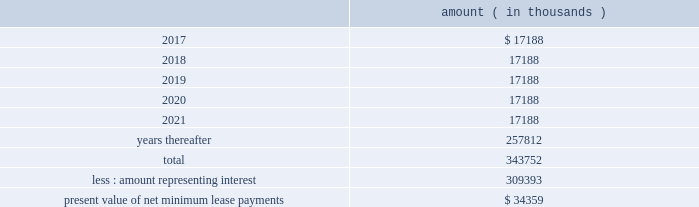Entergy corporation and subsidiaries notes to financial statements liability to $ 60 million , and recorded the $ 2.7 million difference as a credit to interest expense .
The $ 60 million remaining liability was eliminated upon payment of the cash portion of the purchase price .
As of december 31 , 2016 , entergy louisiana , in connection with the waterford 3 lease obligation , had a future minimum lease payment ( reflecting an interest rate of 8.09% ( 8.09 % ) ) of $ 57.5 million , including $ 2.3 million in interest , due january 2017 that is recorded as long-term debt .
In february 2017 the leases were terminated and the leased assets were conveyed to entergy louisiana .
Grand gulf lease obligations in 1988 , in two separate but substantially identical transactions , system energy sold and leased back undivided ownership interests in grand gulf for the aggregate sum of $ 500 million .
The initial term of the leases expired in july 2015 .
System energy renewed the leases for fair market value with renewal terms expiring in july 2036 .
At the end of the new lease renewal terms , system energy has the option to repurchase the leased interests in grand gulf or renew the leases at fair market value .
In the event that system energy does not renew or purchase the interests , system energy would surrender such interests and their associated entitlement of grand gulf 2019s capacity and energy .
System energy is required to report the sale-leaseback as a financing transaction in its financial statements .
For financial reporting purposes , system energy expenses the interest portion of the lease obligation and the plant depreciation .
However , operating revenues include the recovery of the lease payments because the transactions are accounted for as a sale and leaseback for ratemaking purposes .
Consistent with a recommendation contained in a ferc audit report , system energy initially recorded as a net regulatory asset the difference between the recovery of the lease payments and the amounts expensed for interest and depreciation and continues to record this difference as a regulatory asset or liability on an ongoing basis , resulting in a zero net balance for the regulatory asset at the end of the lease term .
The amount was a net regulatory liability of $ 55.6 million and $ 55.6 million as of december 31 , 2016 and 2015 , respectively .
As of december 31 , 2016 , system energy , in connection with the grand gulf sale and leaseback transactions , had future minimum lease payments ( reflecting an implicit rate of 5.13% ( 5.13 % ) ) that are recorded as long-term debt , as follows : amount ( in thousands ) .

What are the implicit interest costs for the 2018 lease payments , in thousands? 
Computations: ((5.13 / 100) * 17188)
Answer: 881.7444. 